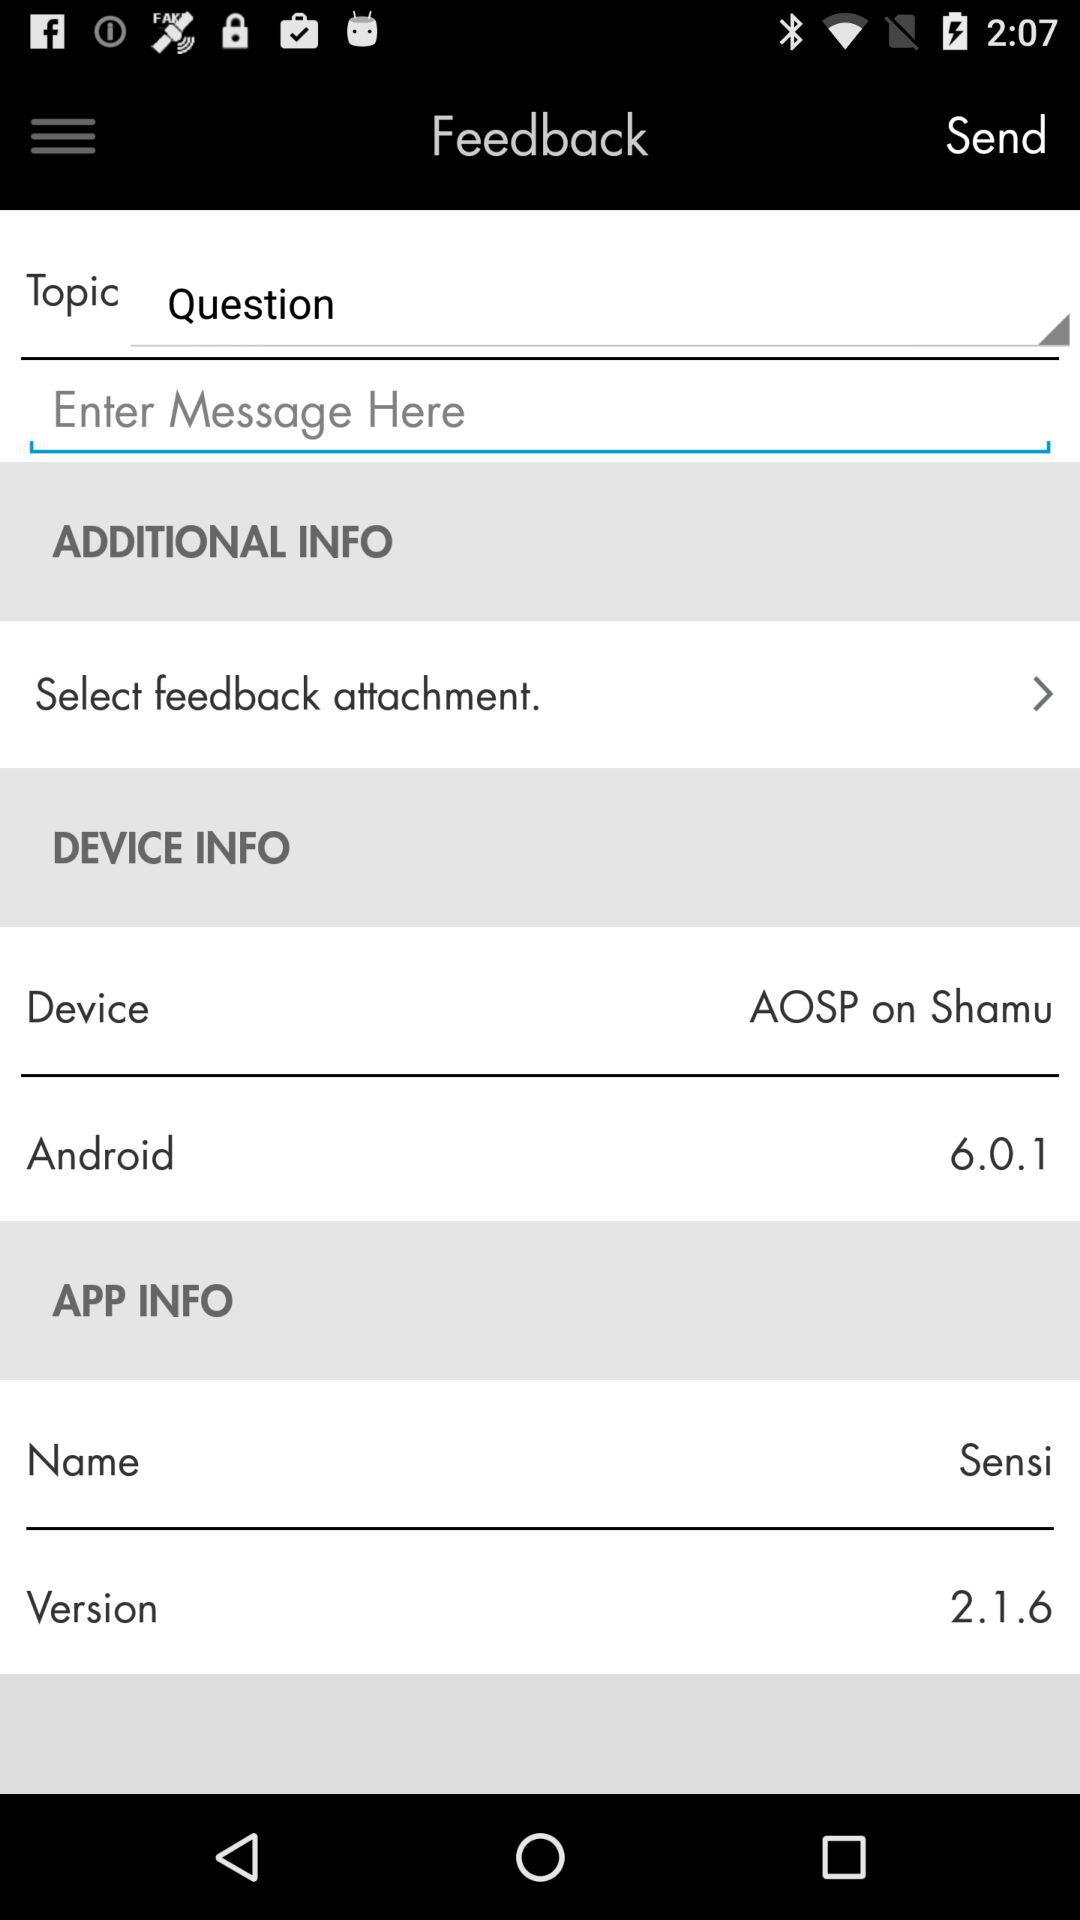What is the topic? The topic is "Question". 